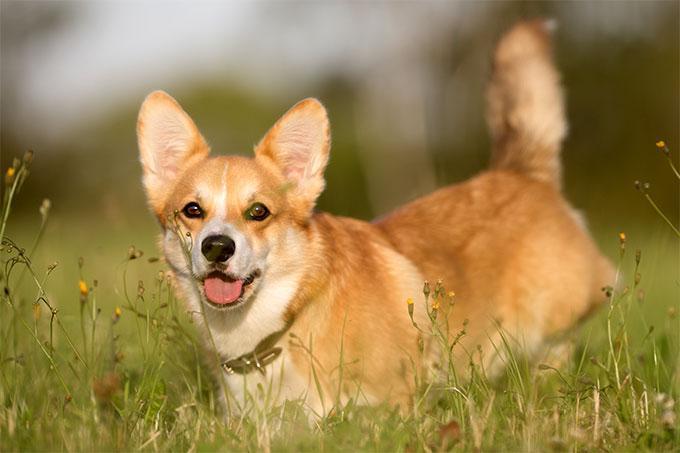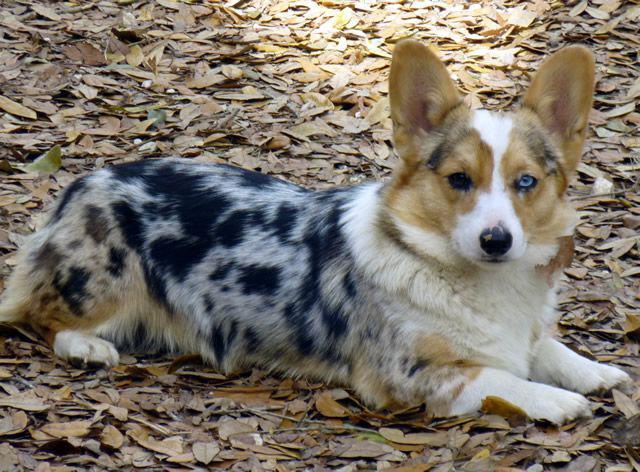The first image is the image on the left, the second image is the image on the right. Given the left and right images, does the statement "The dog in the right image is not posed with grass in the background." hold true? Answer yes or no. Yes. 